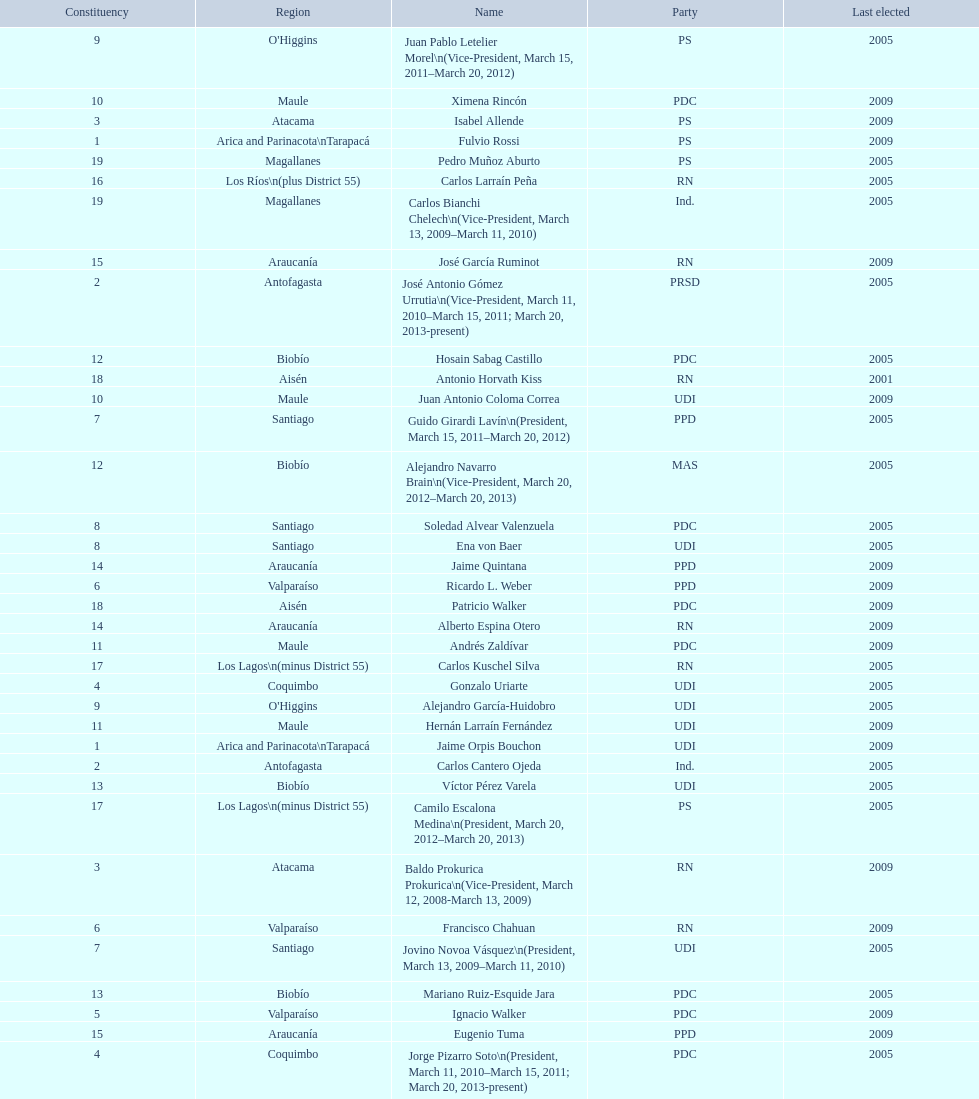When was antonio horvath kiss last elected? 2001. 